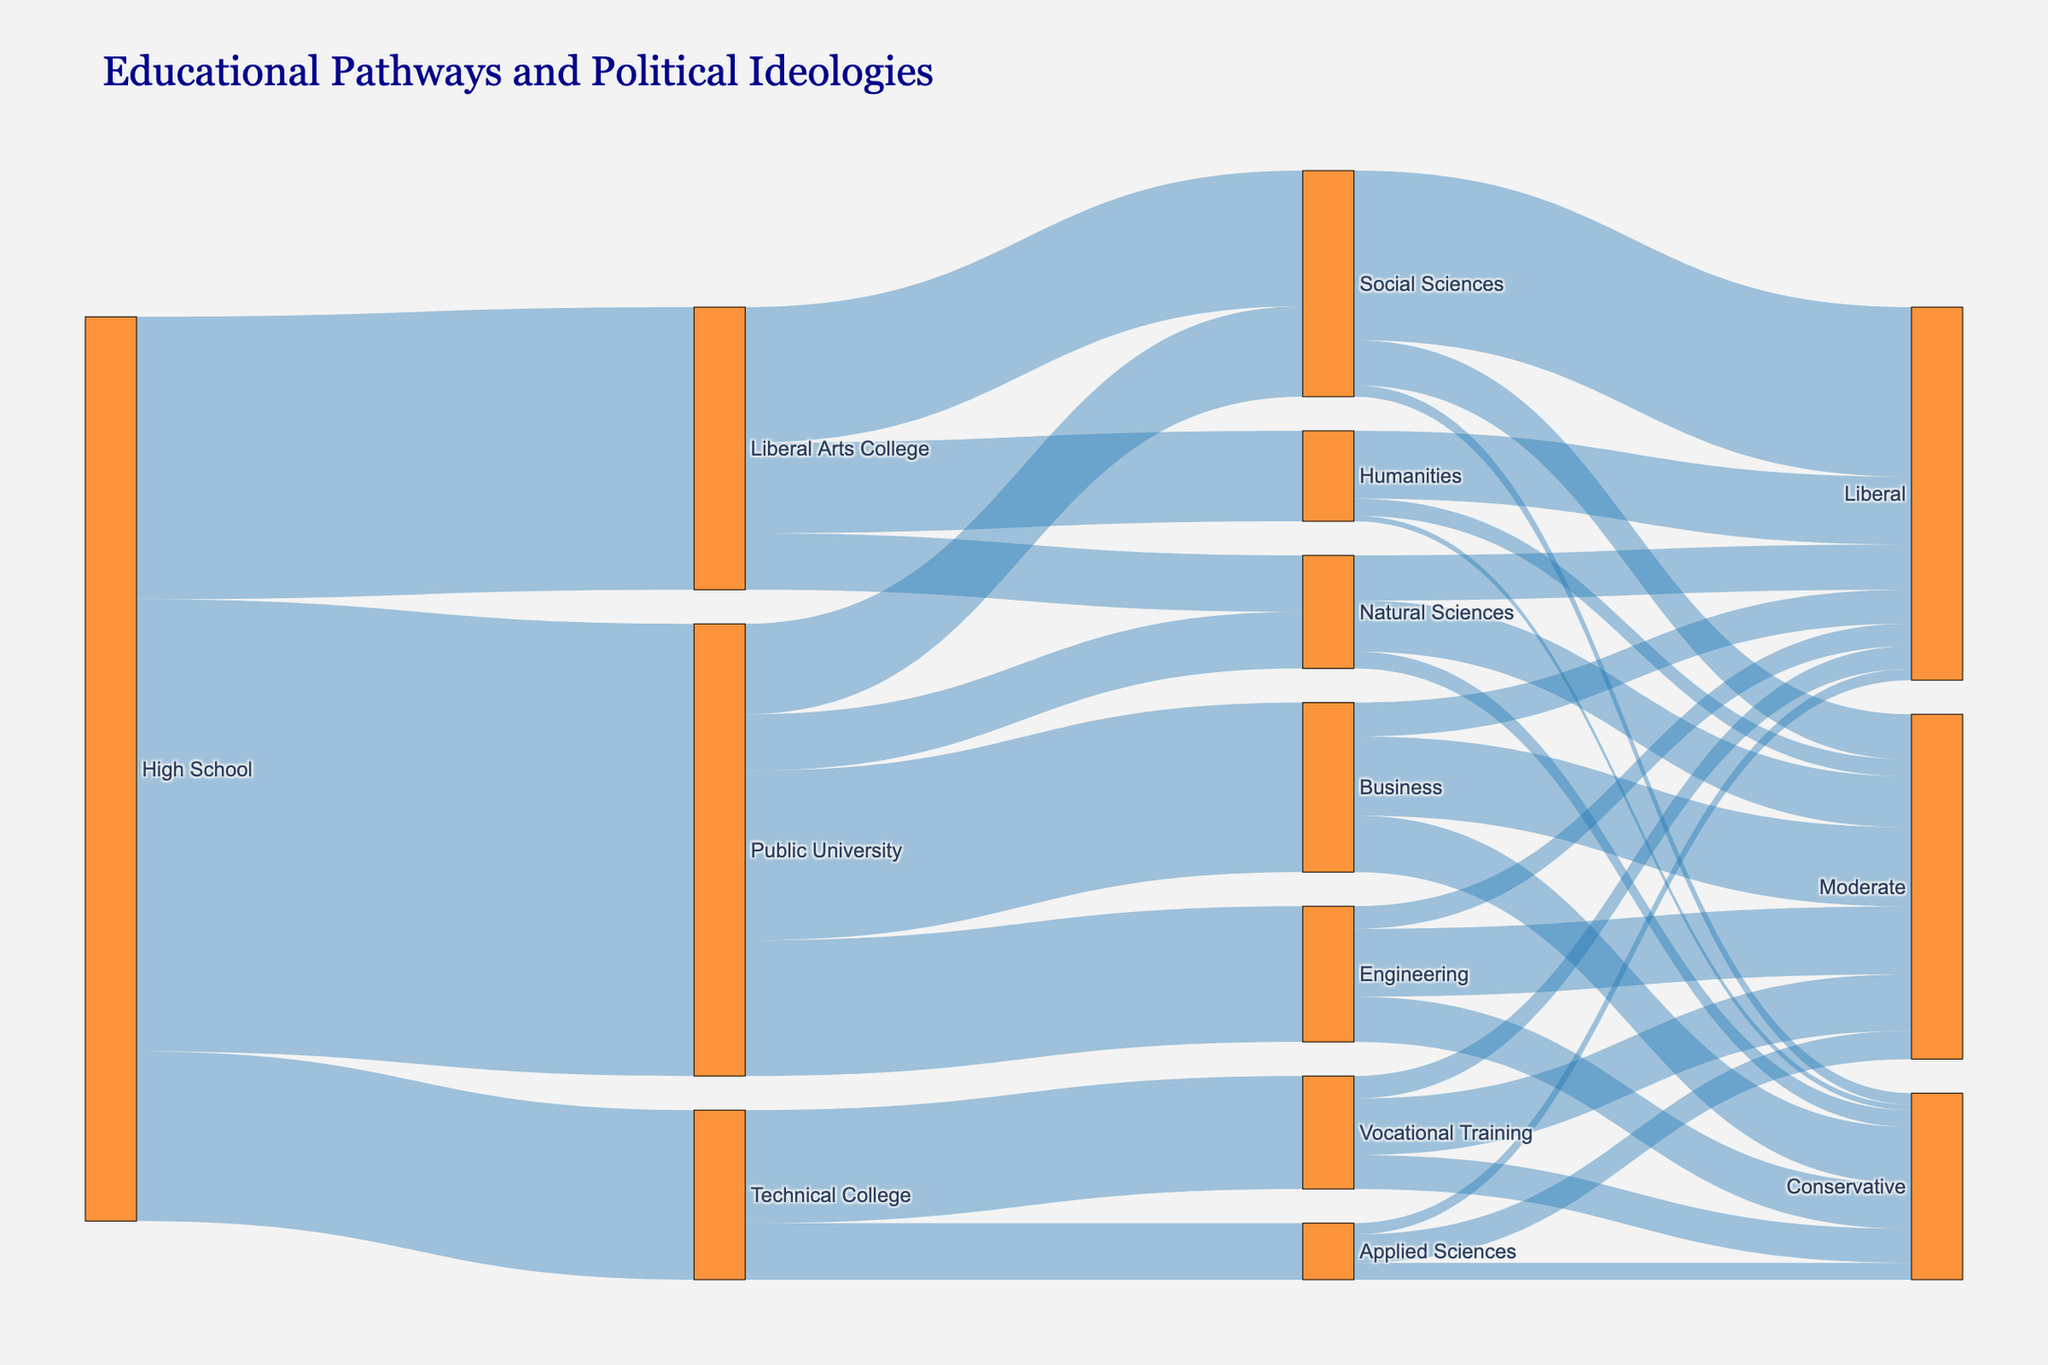How many students from High School go to Public University? By examining the segment labeled "High School" that directly flows to "Public University," it indicates a flow value of 4000.
Answer: 4000 Which political ideology do most Social Sciences graduates align with? To determine this, look for the flows from "Social Sciences" to the political ideologies. The largest flow value is from "Social Sciences" to "Liberal," marked with a value of 1500.
Answer: Liberal What is the total number of students who pursued Liberal Arts College but did not choose Humanities? Sum the flow values from "Liberal Arts College" to the other fields except "Humanities." These values are 1200 (Social Sciences) + 500 (Natural Sciences) = 1700.
Answer: 1700 Between Liberal Arts College graduates in Social Sciences and Public University graduates in Engineering, which group has more students aligning with a Liberal ideology? Compare the Liberal flow values from "Social Sciences" (1200) and "Engineering" (200). We see that Social Sciences has a greater number aligning with Liberal ideology.
Answer: Social Sciences Is the proportion of Vocational Training graduates who align with conservative ideology higher than that of Applied Sciences graduates aligning with the same ideology? Calculate the proportions for each. Vocational Training: 300/1000 = 0.3 (or 30%), Applied Sciences: 150/500 = 0.3 (or 30%). Both have the same proportion.
Answer: No How many students who attended Technical College continue to pursue higher education in Applied Sciences? Look for the flow from "Technical College" to "Applied Sciences," which indicates a value of 500.
Answer: 500 Which field within Public University has the least number of students aligning with a Moderate ideology? Compare the Moderate flow values among Public University fields: 700 (Business), 600 (Engineering), 450 (Natural Sciences), 400 (Social Sciences). Social Sciences has the smallest number aligning with Moderate ideology.
Answer: Social Sciences What are the total number of students in Natural Sciences from both Liberal Arts College and Public University? Sum the flow values from "Liberal Arts College" to "Natural Sciences" (500) and from "Public University" to "Natural Sciences" (500): 500 + 500 = 1000.
Answer: 1000 What is the aggregate number of students from Technical College who don't align with a Liberal ideology? First, sum the flows from "Technical College" to each political ideology: Moderate (500) + Conservative (300). Then add these values: 500 + 300 = 800.
Answer: 800 Which educational pathway has the most significant number of students aligning with Conservative beliefs? Check all the flows that end in "Conservative" and identify the highest value. The flow from "Business" to "Conservative" has a value of 500, the highest among other pathways.
Answer: Business 